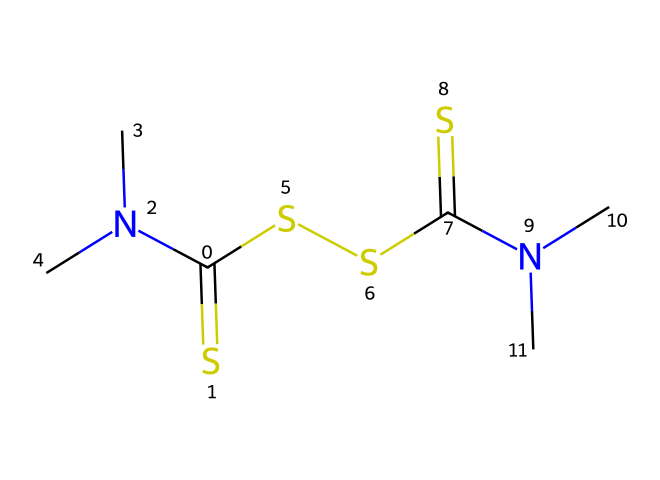How many sulfur atoms are present in thiram? In the provided SMILES, the 'S' represents sulfur atoms. Counting the number of 'S' gives us 4 sulfur atoms in total.
Answer: 4 What functional groups are present in thiram? Looking at the SMILES, we can identify the presence of a thiocarbamate group due to the arrangement of sulfur and nitrogen around the carbon. There are also amine groups (due to the nitrogen attached to methyl groups).
Answer: thiocarbamate and amine What is the total number of nitrogen atoms in thiram? The 'N' in the SMILES notation indicates nitrogen atoms. In total, we can see there are 2 nitrogen atoms present in thiram.
Answer: 2 How many carbon atoms are in thiram? The 'C' in the SMILES notation indicates carbon atoms. By counting the number of 'C', we find there are 6 carbon atoms in the structure of thiram.
Answer: 6 What type of pesticide is thiram classified as? Thiram contains components such as thiocarbamates which are widely recognized as anti-fungal agents in agricultural contexts. Hence, it is specifically classified as a fungicide.
Answer: fungicide Which elements make up the majority of thiram's structure? The SMILES representation shows C (carbon), H (hydrogen), N (nitrogen), and S (sulfur). Among these elements, carbon is the most abundant, as 6 carbon atoms are present compared to fewer counts for others.
Answer: carbon 